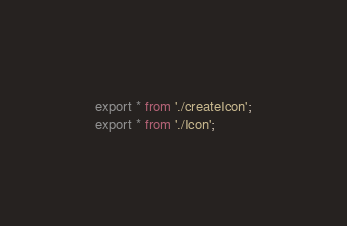<code> <loc_0><loc_0><loc_500><loc_500><_TypeScript_>export * from './createIcon';
export * from './Icon';
</code> 